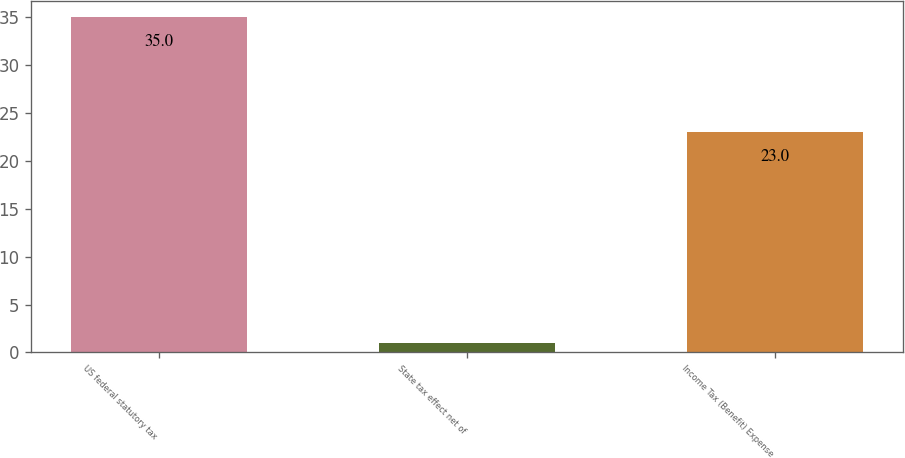Convert chart to OTSL. <chart><loc_0><loc_0><loc_500><loc_500><bar_chart><fcel>US federal statutory tax<fcel>State tax effect net of<fcel>Income Tax (Benefit) Expense<nl><fcel>35<fcel>1<fcel>23<nl></chart> 